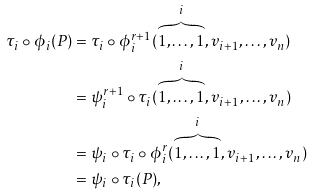Convert formula to latex. <formula><loc_0><loc_0><loc_500><loc_500>\tau _ { i } \circ \phi _ { i } ( P ) & = \tau _ { i } \circ \phi _ { i } ^ { r + 1 } ( \overbrace { 1 , \dots , 1 } ^ { i } , v _ { i + 1 } , \dots , v _ { n } ) \\ & = \psi _ { i } ^ { r + 1 } \circ \tau _ { i } ( \overbrace { 1 , \dots , 1 } ^ { i } , v _ { i + 1 } , \dots , v _ { n } ) \\ & = \psi _ { i } \circ \tau _ { i } \circ \phi _ { i } ^ { r } ( \overbrace { 1 , \dots , 1 } ^ { i } , v _ { i + 1 } , \dots , v _ { n } ) \\ & = \psi _ { i } \circ \tau _ { i } ( P ) ,</formula> 